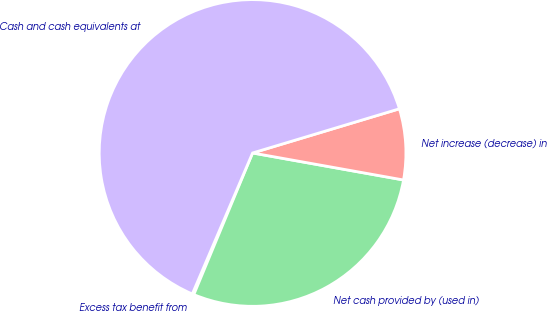<chart> <loc_0><loc_0><loc_500><loc_500><pie_chart><fcel>Excess tax benefit from<fcel>Net cash provided by (used in)<fcel>Net increase (decrease) in<fcel>Cash and cash equivalents at<nl><fcel>0.17%<fcel>28.44%<fcel>7.47%<fcel>63.92%<nl></chart> 